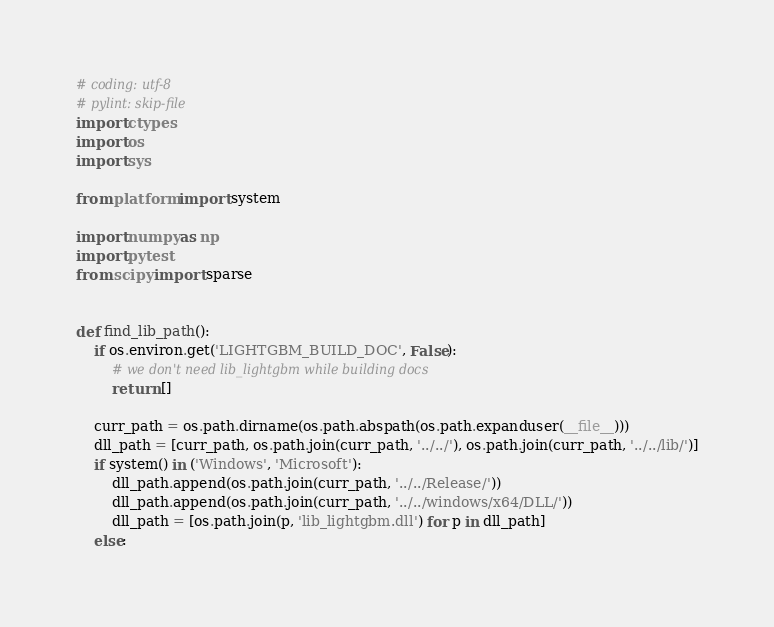<code> <loc_0><loc_0><loc_500><loc_500><_Python_># coding: utf-8
# pylint: skip-file
import ctypes
import os
import sys

from platform import system

import numpy as np
import pytest
from scipy import sparse


def find_lib_path():
    if os.environ.get('LIGHTGBM_BUILD_DOC', False):
        # we don't need lib_lightgbm while building docs
        return []

    curr_path = os.path.dirname(os.path.abspath(os.path.expanduser(__file__)))
    dll_path = [curr_path, os.path.join(curr_path, '../../'), os.path.join(curr_path, '../../lib/')]
    if system() in ('Windows', 'Microsoft'):
        dll_path.append(os.path.join(curr_path, '../../Release/'))
        dll_path.append(os.path.join(curr_path, '../../windows/x64/DLL/'))
        dll_path = [os.path.join(p, 'lib_lightgbm.dll') for p in dll_path]
    else:</code> 